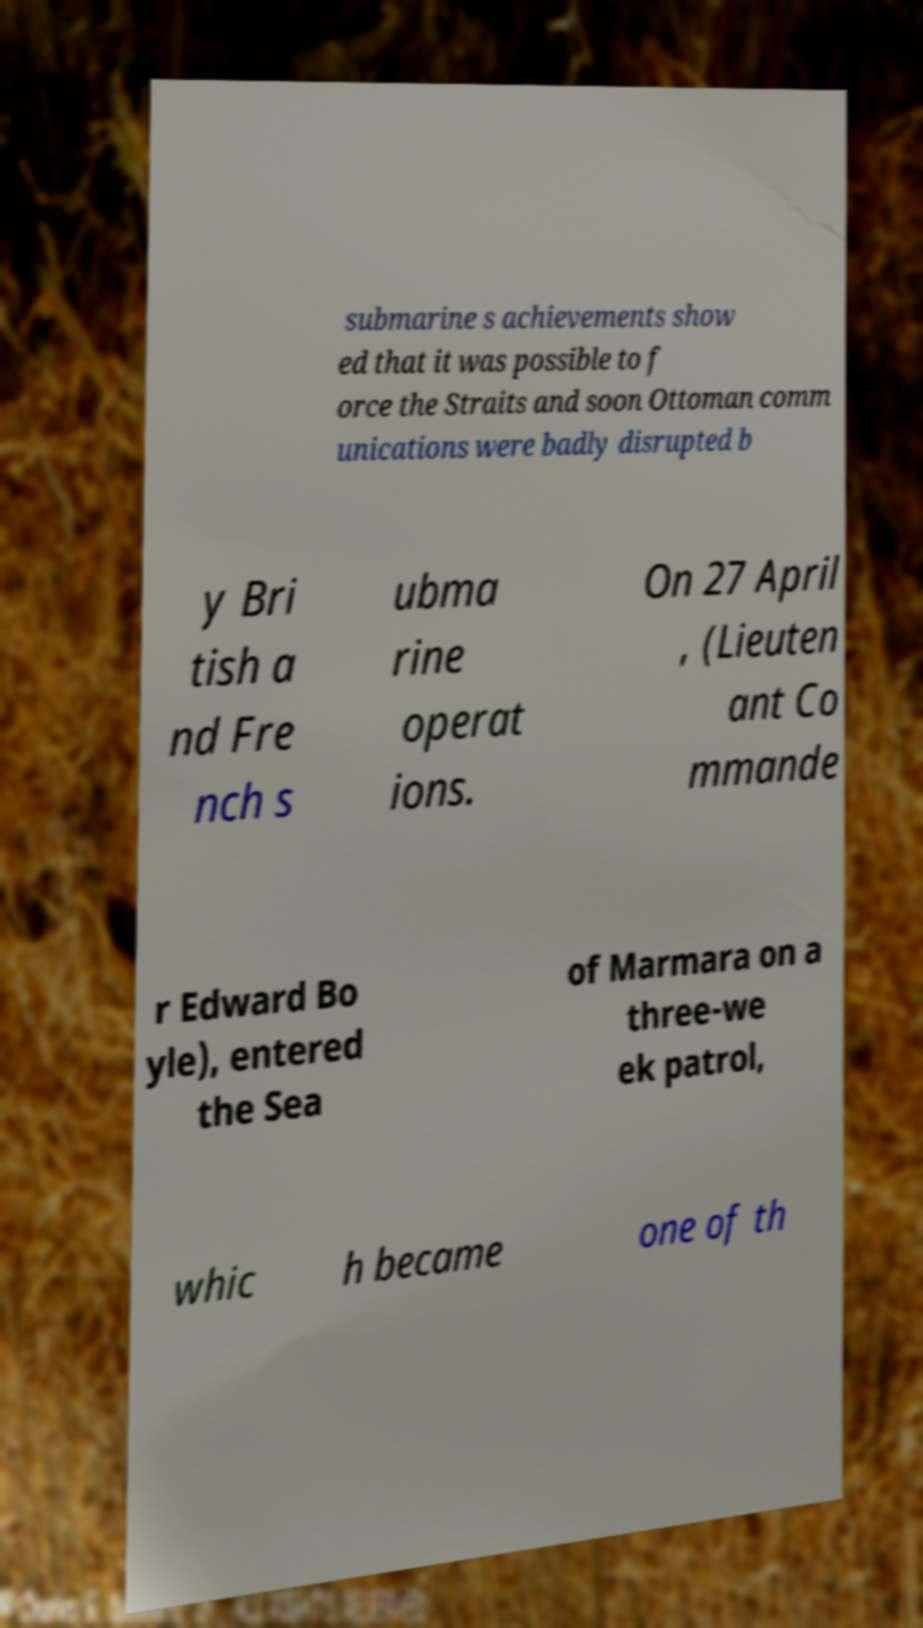Can you read and provide the text displayed in the image?This photo seems to have some interesting text. Can you extract and type it out for me? submarine s achievements show ed that it was possible to f orce the Straits and soon Ottoman comm unications were badly disrupted b y Bri tish a nd Fre nch s ubma rine operat ions. On 27 April , (Lieuten ant Co mmande r Edward Bo yle), entered the Sea of Marmara on a three-we ek patrol, whic h became one of th 